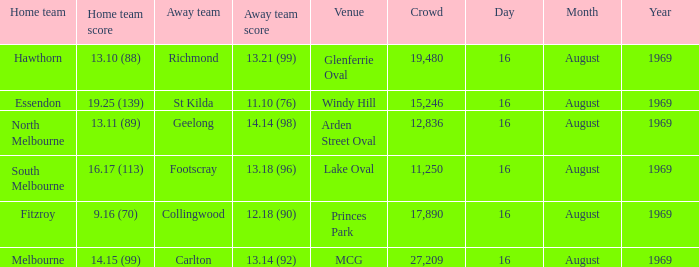What was the away team when the game was at Princes Park? Collingwood. 